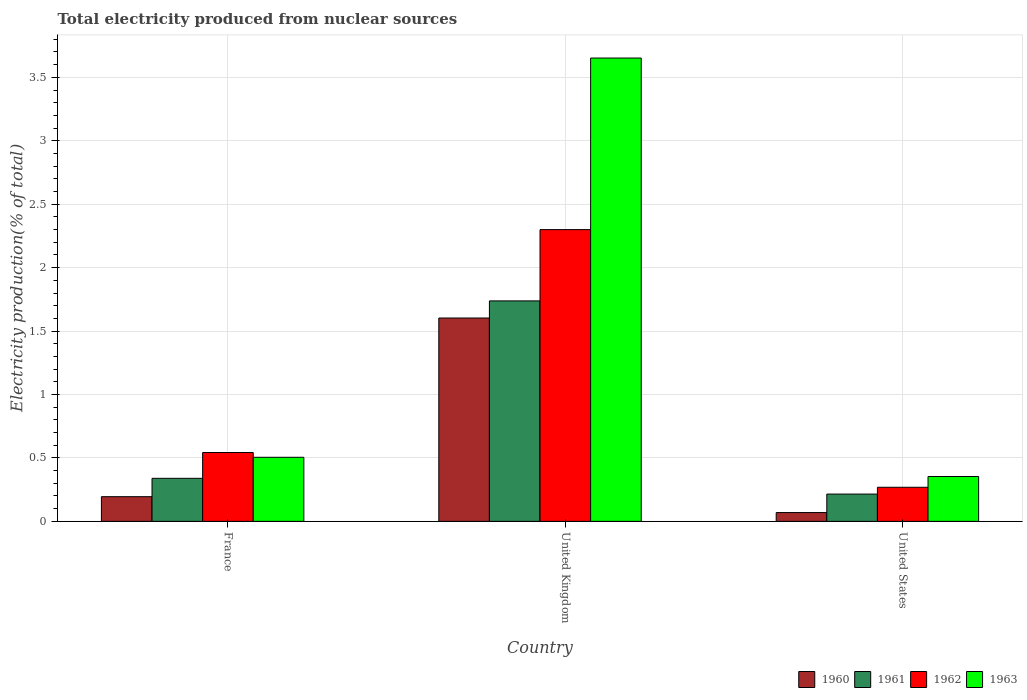How many groups of bars are there?
Offer a terse response. 3. Are the number of bars per tick equal to the number of legend labels?
Make the answer very short. Yes. How many bars are there on the 3rd tick from the right?
Your answer should be compact. 4. What is the label of the 1st group of bars from the left?
Provide a succinct answer. France. What is the total electricity produced in 1962 in United Kingdom?
Provide a succinct answer. 2.3. Across all countries, what is the maximum total electricity produced in 1960?
Provide a short and direct response. 1.6. Across all countries, what is the minimum total electricity produced in 1960?
Offer a terse response. 0.07. In which country was the total electricity produced in 1961 maximum?
Provide a succinct answer. United Kingdom. What is the total total electricity produced in 1963 in the graph?
Make the answer very short. 4.51. What is the difference between the total electricity produced in 1960 in France and that in United Kingdom?
Give a very brief answer. -1.41. What is the difference between the total electricity produced in 1963 in United States and the total electricity produced in 1961 in United Kingdom?
Make the answer very short. -1.38. What is the average total electricity produced in 1962 per country?
Offer a terse response. 1.04. What is the difference between the total electricity produced of/in 1963 and total electricity produced of/in 1961 in United Kingdom?
Provide a succinct answer. 1.91. What is the ratio of the total electricity produced in 1961 in France to that in United States?
Provide a succinct answer. 1.58. Is the total electricity produced in 1963 in France less than that in United Kingdom?
Your answer should be very brief. Yes. What is the difference between the highest and the second highest total electricity produced in 1960?
Provide a short and direct response. -1.41. What is the difference between the highest and the lowest total electricity produced in 1960?
Keep it short and to the point. 1.53. Is it the case that in every country, the sum of the total electricity produced in 1963 and total electricity produced in 1960 is greater than the sum of total electricity produced in 1961 and total electricity produced in 1962?
Give a very brief answer. No. What does the 1st bar from the left in United States represents?
Offer a terse response. 1960. What does the 4th bar from the right in United Kingdom represents?
Your answer should be very brief. 1960. How many countries are there in the graph?
Give a very brief answer. 3. Does the graph contain grids?
Keep it short and to the point. Yes. Where does the legend appear in the graph?
Make the answer very short. Bottom right. What is the title of the graph?
Give a very brief answer. Total electricity produced from nuclear sources. What is the label or title of the Y-axis?
Offer a terse response. Electricity production(% of total). What is the Electricity production(% of total) of 1960 in France?
Keep it short and to the point. 0.19. What is the Electricity production(% of total) of 1961 in France?
Make the answer very short. 0.34. What is the Electricity production(% of total) in 1962 in France?
Offer a terse response. 0.54. What is the Electricity production(% of total) of 1963 in France?
Make the answer very short. 0.51. What is the Electricity production(% of total) in 1960 in United Kingdom?
Your response must be concise. 1.6. What is the Electricity production(% of total) of 1961 in United Kingdom?
Offer a terse response. 1.74. What is the Electricity production(% of total) in 1962 in United Kingdom?
Keep it short and to the point. 2.3. What is the Electricity production(% of total) of 1963 in United Kingdom?
Make the answer very short. 3.65. What is the Electricity production(% of total) of 1960 in United States?
Offer a terse response. 0.07. What is the Electricity production(% of total) of 1961 in United States?
Your answer should be very brief. 0.22. What is the Electricity production(% of total) of 1962 in United States?
Provide a short and direct response. 0.27. What is the Electricity production(% of total) in 1963 in United States?
Provide a succinct answer. 0.35. Across all countries, what is the maximum Electricity production(% of total) of 1960?
Provide a short and direct response. 1.6. Across all countries, what is the maximum Electricity production(% of total) in 1961?
Keep it short and to the point. 1.74. Across all countries, what is the maximum Electricity production(% of total) in 1962?
Offer a terse response. 2.3. Across all countries, what is the maximum Electricity production(% of total) of 1963?
Your answer should be compact. 3.65. Across all countries, what is the minimum Electricity production(% of total) in 1960?
Ensure brevity in your answer.  0.07. Across all countries, what is the minimum Electricity production(% of total) of 1961?
Provide a succinct answer. 0.22. Across all countries, what is the minimum Electricity production(% of total) in 1962?
Make the answer very short. 0.27. Across all countries, what is the minimum Electricity production(% of total) of 1963?
Keep it short and to the point. 0.35. What is the total Electricity production(% of total) of 1960 in the graph?
Offer a very short reply. 1.87. What is the total Electricity production(% of total) of 1961 in the graph?
Make the answer very short. 2.29. What is the total Electricity production(% of total) of 1962 in the graph?
Offer a very short reply. 3.11. What is the total Electricity production(% of total) in 1963 in the graph?
Provide a succinct answer. 4.51. What is the difference between the Electricity production(% of total) of 1960 in France and that in United Kingdom?
Offer a very short reply. -1.41. What is the difference between the Electricity production(% of total) of 1961 in France and that in United Kingdom?
Give a very brief answer. -1.4. What is the difference between the Electricity production(% of total) in 1962 in France and that in United Kingdom?
Offer a terse response. -1.76. What is the difference between the Electricity production(% of total) of 1963 in France and that in United Kingdom?
Provide a short and direct response. -3.15. What is the difference between the Electricity production(% of total) of 1960 in France and that in United States?
Your response must be concise. 0.13. What is the difference between the Electricity production(% of total) of 1961 in France and that in United States?
Make the answer very short. 0.12. What is the difference between the Electricity production(% of total) in 1962 in France and that in United States?
Ensure brevity in your answer.  0.27. What is the difference between the Electricity production(% of total) of 1963 in France and that in United States?
Ensure brevity in your answer.  0.15. What is the difference between the Electricity production(% of total) in 1960 in United Kingdom and that in United States?
Your answer should be compact. 1.53. What is the difference between the Electricity production(% of total) of 1961 in United Kingdom and that in United States?
Offer a terse response. 1.52. What is the difference between the Electricity production(% of total) in 1962 in United Kingdom and that in United States?
Your response must be concise. 2.03. What is the difference between the Electricity production(% of total) of 1963 in United Kingdom and that in United States?
Give a very brief answer. 3.3. What is the difference between the Electricity production(% of total) in 1960 in France and the Electricity production(% of total) in 1961 in United Kingdom?
Your response must be concise. -1.54. What is the difference between the Electricity production(% of total) in 1960 in France and the Electricity production(% of total) in 1962 in United Kingdom?
Provide a short and direct response. -2.11. What is the difference between the Electricity production(% of total) of 1960 in France and the Electricity production(% of total) of 1963 in United Kingdom?
Keep it short and to the point. -3.46. What is the difference between the Electricity production(% of total) of 1961 in France and the Electricity production(% of total) of 1962 in United Kingdom?
Offer a very short reply. -1.96. What is the difference between the Electricity production(% of total) of 1961 in France and the Electricity production(% of total) of 1963 in United Kingdom?
Your response must be concise. -3.31. What is the difference between the Electricity production(% of total) in 1962 in France and the Electricity production(% of total) in 1963 in United Kingdom?
Your answer should be compact. -3.11. What is the difference between the Electricity production(% of total) of 1960 in France and the Electricity production(% of total) of 1961 in United States?
Provide a short and direct response. -0.02. What is the difference between the Electricity production(% of total) of 1960 in France and the Electricity production(% of total) of 1962 in United States?
Make the answer very short. -0.07. What is the difference between the Electricity production(% of total) of 1960 in France and the Electricity production(% of total) of 1963 in United States?
Provide a short and direct response. -0.16. What is the difference between the Electricity production(% of total) of 1961 in France and the Electricity production(% of total) of 1962 in United States?
Offer a very short reply. 0.07. What is the difference between the Electricity production(% of total) in 1961 in France and the Electricity production(% of total) in 1963 in United States?
Your answer should be compact. -0.01. What is the difference between the Electricity production(% of total) in 1962 in France and the Electricity production(% of total) in 1963 in United States?
Your response must be concise. 0.19. What is the difference between the Electricity production(% of total) in 1960 in United Kingdom and the Electricity production(% of total) in 1961 in United States?
Your answer should be very brief. 1.39. What is the difference between the Electricity production(% of total) in 1960 in United Kingdom and the Electricity production(% of total) in 1962 in United States?
Give a very brief answer. 1.33. What is the difference between the Electricity production(% of total) of 1960 in United Kingdom and the Electricity production(% of total) of 1963 in United States?
Provide a short and direct response. 1.25. What is the difference between the Electricity production(% of total) in 1961 in United Kingdom and the Electricity production(% of total) in 1962 in United States?
Provide a short and direct response. 1.47. What is the difference between the Electricity production(% of total) of 1961 in United Kingdom and the Electricity production(% of total) of 1963 in United States?
Your response must be concise. 1.38. What is the difference between the Electricity production(% of total) in 1962 in United Kingdom and the Electricity production(% of total) in 1963 in United States?
Provide a short and direct response. 1.95. What is the average Electricity production(% of total) in 1960 per country?
Your response must be concise. 0.62. What is the average Electricity production(% of total) of 1961 per country?
Give a very brief answer. 0.76. What is the average Electricity production(% of total) of 1963 per country?
Offer a terse response. 1.5. What is the difference between the Electricity production(% of total) of 1960 and Electricity production(% of total) of 1961 in France?
Your response must be concise. -0.14. What is the difference between the Electricity production(% of total) in 1960 and Electricity production(% of total) in 1962 in France?
Offer a very short reply. -0.35. What is the difference between the Electricity production(% of total) of 1960 and Electricity production(% of total) of 1963 in France?
Your answer should be very brief. -0.31. What is the difference between the Electricity production(% of total) in 1961 and Electricity production(% of total) in 1962 in France?
Give a very brief answer. -0.2. What is the difference between the Electricity production(% of total) of 1961 and Electricity production(% of total) of 1963 in France?
Your answer should be very brief. -0.17. What is the difference between the Electricity production(% of total) of 1962 and Electricity production(% of total) of 1963 in France?
Your answer should be very brief. 0.04. What is the difference between the Electricity production(% of total) of 1960 and Electricity production(% of total) of 1961 in United Kingdom?
Give a very brief answer. -0.13. What is the difference between the Electricity production(% of total) of 1960 and Electricity production(% of total) of 1962 in United Kingdom?
Ensure brevity in your answer.  -0.7. What is the difference between the Electricity production(% of total) of 1960 and Electricity production(% of total) of 1963 in United Kingdom?
Your answer should be compact. -2.05. What is the difference between the Electricity production(% of total) of 1961 and Electricity production(% of total) of 1962 in United Kingdom?
Your answer should be compact. -0.56. What is the difference between the Electricity production(% of total) of 1961 and Electricity production(% of total) of 1963 in United Kingdom?
Provide a succinct answer. -1.91. What is the difference between the Electricity production(% of total) in 1962 and Electricity production(% of total) in 1963 in United Kingdom?
Give a very brief answer. -1.35. What is the difference between the Electricity production(% of total) of 1960 and Electricity production(% of total) of 1961 in United States?
Your response must be concise. -0.15. What is the difference between the Electricity production(% of total) of 1960 and Electricity production(% of total) of 1962 in United States?
Provide a succinct answer. -0.2. What is the difference between the Electricity production(% of total) in 1960 and Electricity production(% of total) in 1963 in United States?
Your answer should be very brief. -0.28. What is the difference between the Electricity production(% of total) in 1961 and Electricity production(% of total) in 1962 in United States?
Provide a short and direct response. -0.05. What is the difference between the Electricity production(% of total) in 1961 and Electricity production(% of total) in 1963 in United States?
Ensure brevity in your answer.  -0.14. What is the difference between the Electricity production(% of total) of 1962 and Electricity production(% of total) of 1963 in United States?
Offer a very short reply. -0.09. What is the ratio of the Electricity production(% of total) of 1960 in France to that in United Kingdom?
Offer a terse response. 0.12. What is the ratio of the Electricity production(% of total) in 1961 in France to that in United Kingdom?
Provide a short and direct response. 0.2. What is the ratio of the Electricity production(% of total) in 1962 in France to that in United Kingdom?
Make the answer very short. 0.24. What is the ratio of the Electricity production(% of total) of 1963 in France to that in United Kingdom?
Ensure brevity in your answer.  0.14. What is the ratio of the Electricity production(% of total) of 1960 in France to that in United States?
Provide a short and direct response. 2.81. What is the ratio of the Electricity production(% of total) in 1961 in France to that in United States?
Your answer should be very brief. 1.58. What is the ratio of the Electricity production(% of total) in 1962 in France to that in United States?
Keep it short and to the point. 2.02. What is the ratio of the Electricity production(% of total) in 1963 in France to that in United States?
Provide a succinct answer. 1.43. What is the ratio of the Electricity production(% of total) in 1960 in United Kingdom to that in United States?
Your answer should be very brief. 23.14. What is the ratio of the Electricity production(% of total) in 1961 in United Kingdom to that in United States?
Your response must be concise. 8.08. What is the ratio of the Electricity production(% of total) in 1962 in United Kingdom to that in United States?
Ensure brevity in your answer.  8.56. What is the ratio of the Electricity production(% of total) in 1963 in United Kingdom to that in United States?
Offer a terse response. 10.32. What is the difference between the highest and the second highest Electricity production(% of total) in 1960?
Your answer should be very brief. 1.41. What is the difference between the highest and the second highest Electricity production(% of total) of 1961?
Offer a very short reply. 1.4. What is the difference between the highest and the second highest Electricity production(% of total) in 1962?
Offer a very short reply. 1.76. What is the difference between the highest and the second highest Electricity production(% of total) of 1963?
Make the answer very short. 3.15. What is the difference between the highest and the lowest Electricity production(% of total) of 1960?
Offer a very short reply. 1.53. What is the difference between the highest and the lowest Electricity production(% of total) of 1961?
Ensure brevity in your answer.  1.52. What is the difference between the highest and the lowest Electricity production(% of total) in 1962?
Offer a very short reply. 2.03. What is the difference between the highest and the lowest Electricity production(% of total) of 1963?
Ensure brevity in your answer.  3.3. 